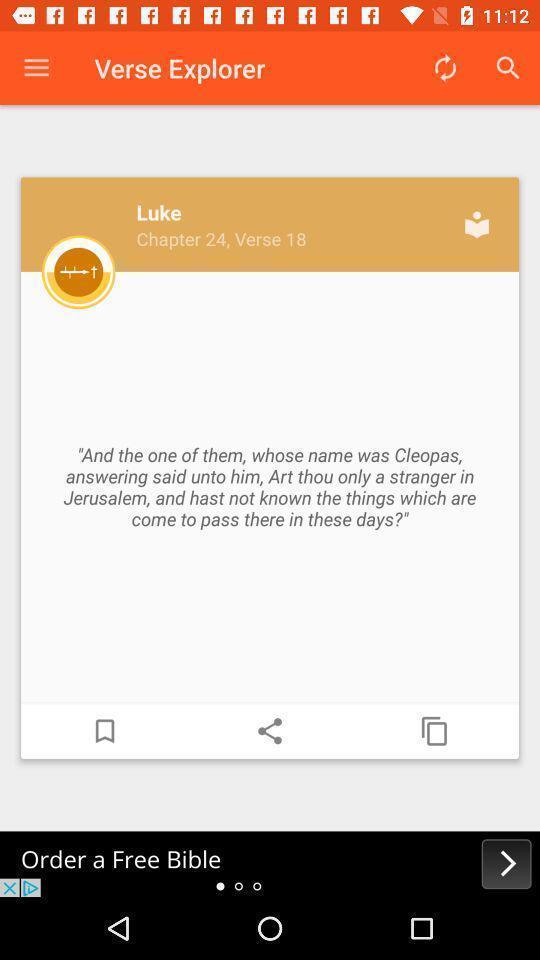Provide a detailed account of this screenshot. Pop up of a luke. 